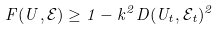<formula> <loc_0><loc_0><loc_500><loc_500>F ( U , \mathcal { E } ) \geq 1 - k ^ { 2 } D ( U _ { t } , \mathcal { E } _ { t } ) ^ { 2 }</formula> 